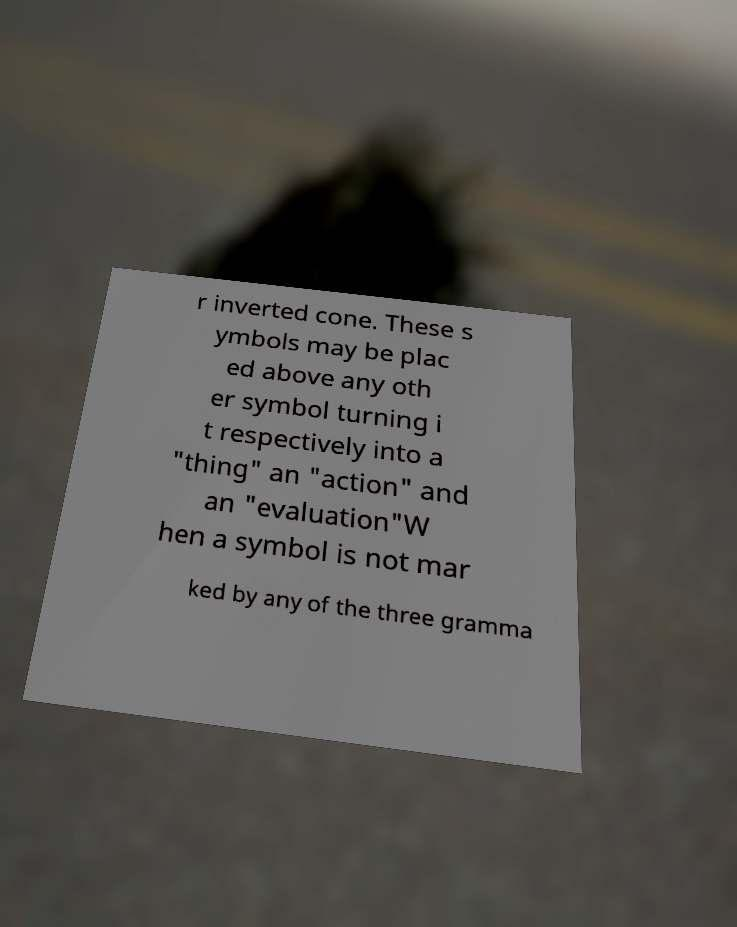Please identify and transcribe the text found in this image. r inverted cone. These s ymbols may be plac ed above any oth er symbol turning i t respectively into a "thing" an "action" and an "evaluation"W hen a symbol is not mar ked by any of the three gramma 